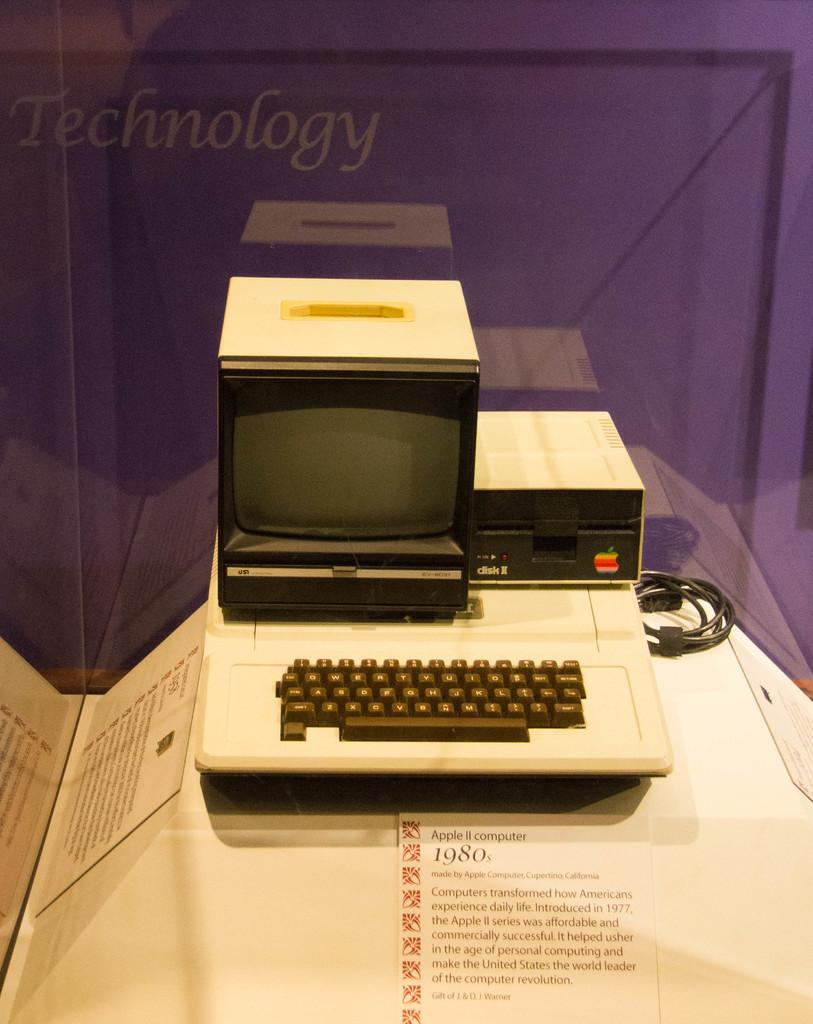Provide a one-sentence caption for the provided image. an old APPLE 2 computer from the 1980's with a purple background that says Technology on it. 